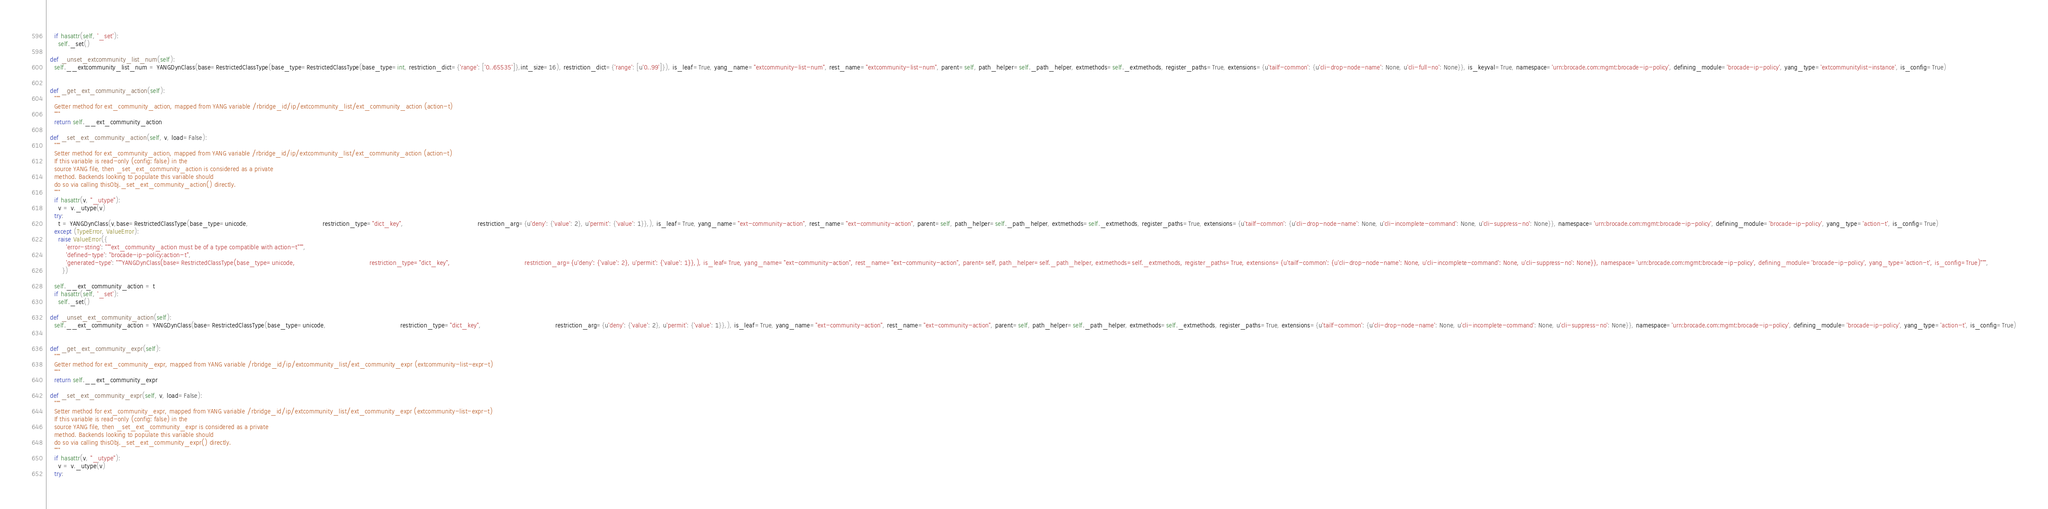<code> <loc_0><loc_0><loc_500><loc_500><_Python_>    if hasattr(self, '_set'):
      self._set()

  def _unset_extcommunity_list_num(self):
    self.__extcommunity_list_num = YANGDynClass(base=RestrictedClassType(base_type=RestrictedClassType(base_type=int, restriction_dict={'range': ['0..65535']},int_size=16), restriction_dict={'range': [u'0..99']}), is_leaf=True, yang_name="extcommunity-list-num", rest_name="extcommunity-list-num", parent=self, path_helper=self._path_helper, extmethods=self._extmethods, register_paths=True, extensions={u'tailf-common': {u'cli-drop-node-name': None, u'cli-full-no': None}}, is_keyval=True, namespace='urn:brocade.com:mgmt:brocade-ip-policy', defining_module='brocade-ip-policy', yang_type='extcommunitylist-instance', is_config=True)


  def _get_ext_community_action(self):
    """
    Getter method for ext_community_action, mapped from YANG variable /rbridge_id/ip/extcommunity_list/ext_community_action (action-t)
    """
    return self.__ext_community_action
      
  def _set_ext_community_action(self, v, load=False):
    """
    Setter method for ext_community_action, mapped from YANG variable /rbridge_id/ip/extcommunity_list/ext_community_action (action-t)
    If this variable is read-only (config: false) in the
    source YANG file, then _set_ext_community_action is considered as a private
    method. Backends looking to populate this variable should
    do so via calling thisObj._set_ext_community_action() directly.
    """
    if hasattr(v, "_utype"):
      v = v._utype(v)
    try:
      t = YANGDynClass(v,base=RestrictedClassType(base_type=unicode,                                     restriction_type="dict_key",                                     restriction_arg={u'deny': {'value': 2}, u'permit': {'value': 1}},), is_leaf=True, yang_name="ext-community-action", rest_name="ext-community-action", parent=self, path_helper=self._path_helper, extmethods=self._extmethods, register_paths=True, extensions={u'tailf-common': {u'cli-drop-node-name': None, u'cli-incomplete-command': None, u'cli-suppress-no': None}}, namespace='urn:brocade.com:mgmt:brocade-ip-policy', defining_module='brocade-ip-policy', yang_type='action-t', is_config=True)
    except (TypeError, ValueError):
      raise ValueError({
          'error-string': """ext_community_action must be of a type compatible with action-t""",
          'defined-type': "brocade-ip-policy:action-t",
          'generated-type': """YANGDynClass(base=RestrictedClassType(base_type=unicode,                                     restriction_type="dict_key",                                     restriction_arg={u'deny': {'value': 2}, u'permit': {'value': 1}},), is_leaf=True, yang_name="ext-community-action", rest_name="ext-community-action", parent=self, path_helper=self._path_helper, extmethods=self._extmethods, register_paths=True, extensions={u'tailf-common': {u'cli-drop-node-name': None, u'cli-incomplete-command': None, u'cli-suppress-no': None}}, namespace='urn:brocade.com:mgmt:brocade-ip-policy', defining_module='brocade-ip-policy', yang_type='action-t', is_config=True)""",
        })

    self.__ext_community_action = t
    if hasattr(self, '_set'):
      self._set()

  def _unset_ext_community_action(self):
    self.__ext_community_action = YANGDynClass(base=RestrictedClassType(base_type=unicode,                                     restriction_type="dict_key",                                     restriction_arg={u'deny': {'value': 2}, u'permit': {'value': 1}},), is_leaf=True, yang_name="ext-community-action", rest_name="ext-community-action", parent=self, path_helper=self._path_helper, extmethods=self._extmethods, register_paths=True, extensions={u'tailf-common': {u'cli-drop-node-name': None, u'cli-incomplete-command': None, u'cli-suppress-no': None}}, namespace='urn:brocade.com:mgmt:brocade-ip-policy', defining_module='brocade-ip-policy', yang_type='action-t', is_config=True)


  def _get_ext_community_expr(self):
    """
    Getter method for ext_community_expr, mapped from YANG variable /rbridge_id/ip/extcommunity_list/ext_community_expr (extcommunity-list-expr-t)
    """
    return self.__ext_community_expr
      
  def _set_ext_community_expr(self, v, load=False):
    """
    Setter method for ext_community_expr, mapped from YANG variable /rbridge_id/ip/extcommunity_list/ext_community_expr (extcommunity-list-expr-t)
    If this variable is read-only (config: false) in the
    source YANG file, then _set_ext_community_expr is considered as a private
    method. Backends looking to populate this variable should
    do so via calling thisObj._set_ext_community_expr() directly.
    """
    if hasattr(v, "_utype"):
      v = v._utype(v)
    try:</code> 